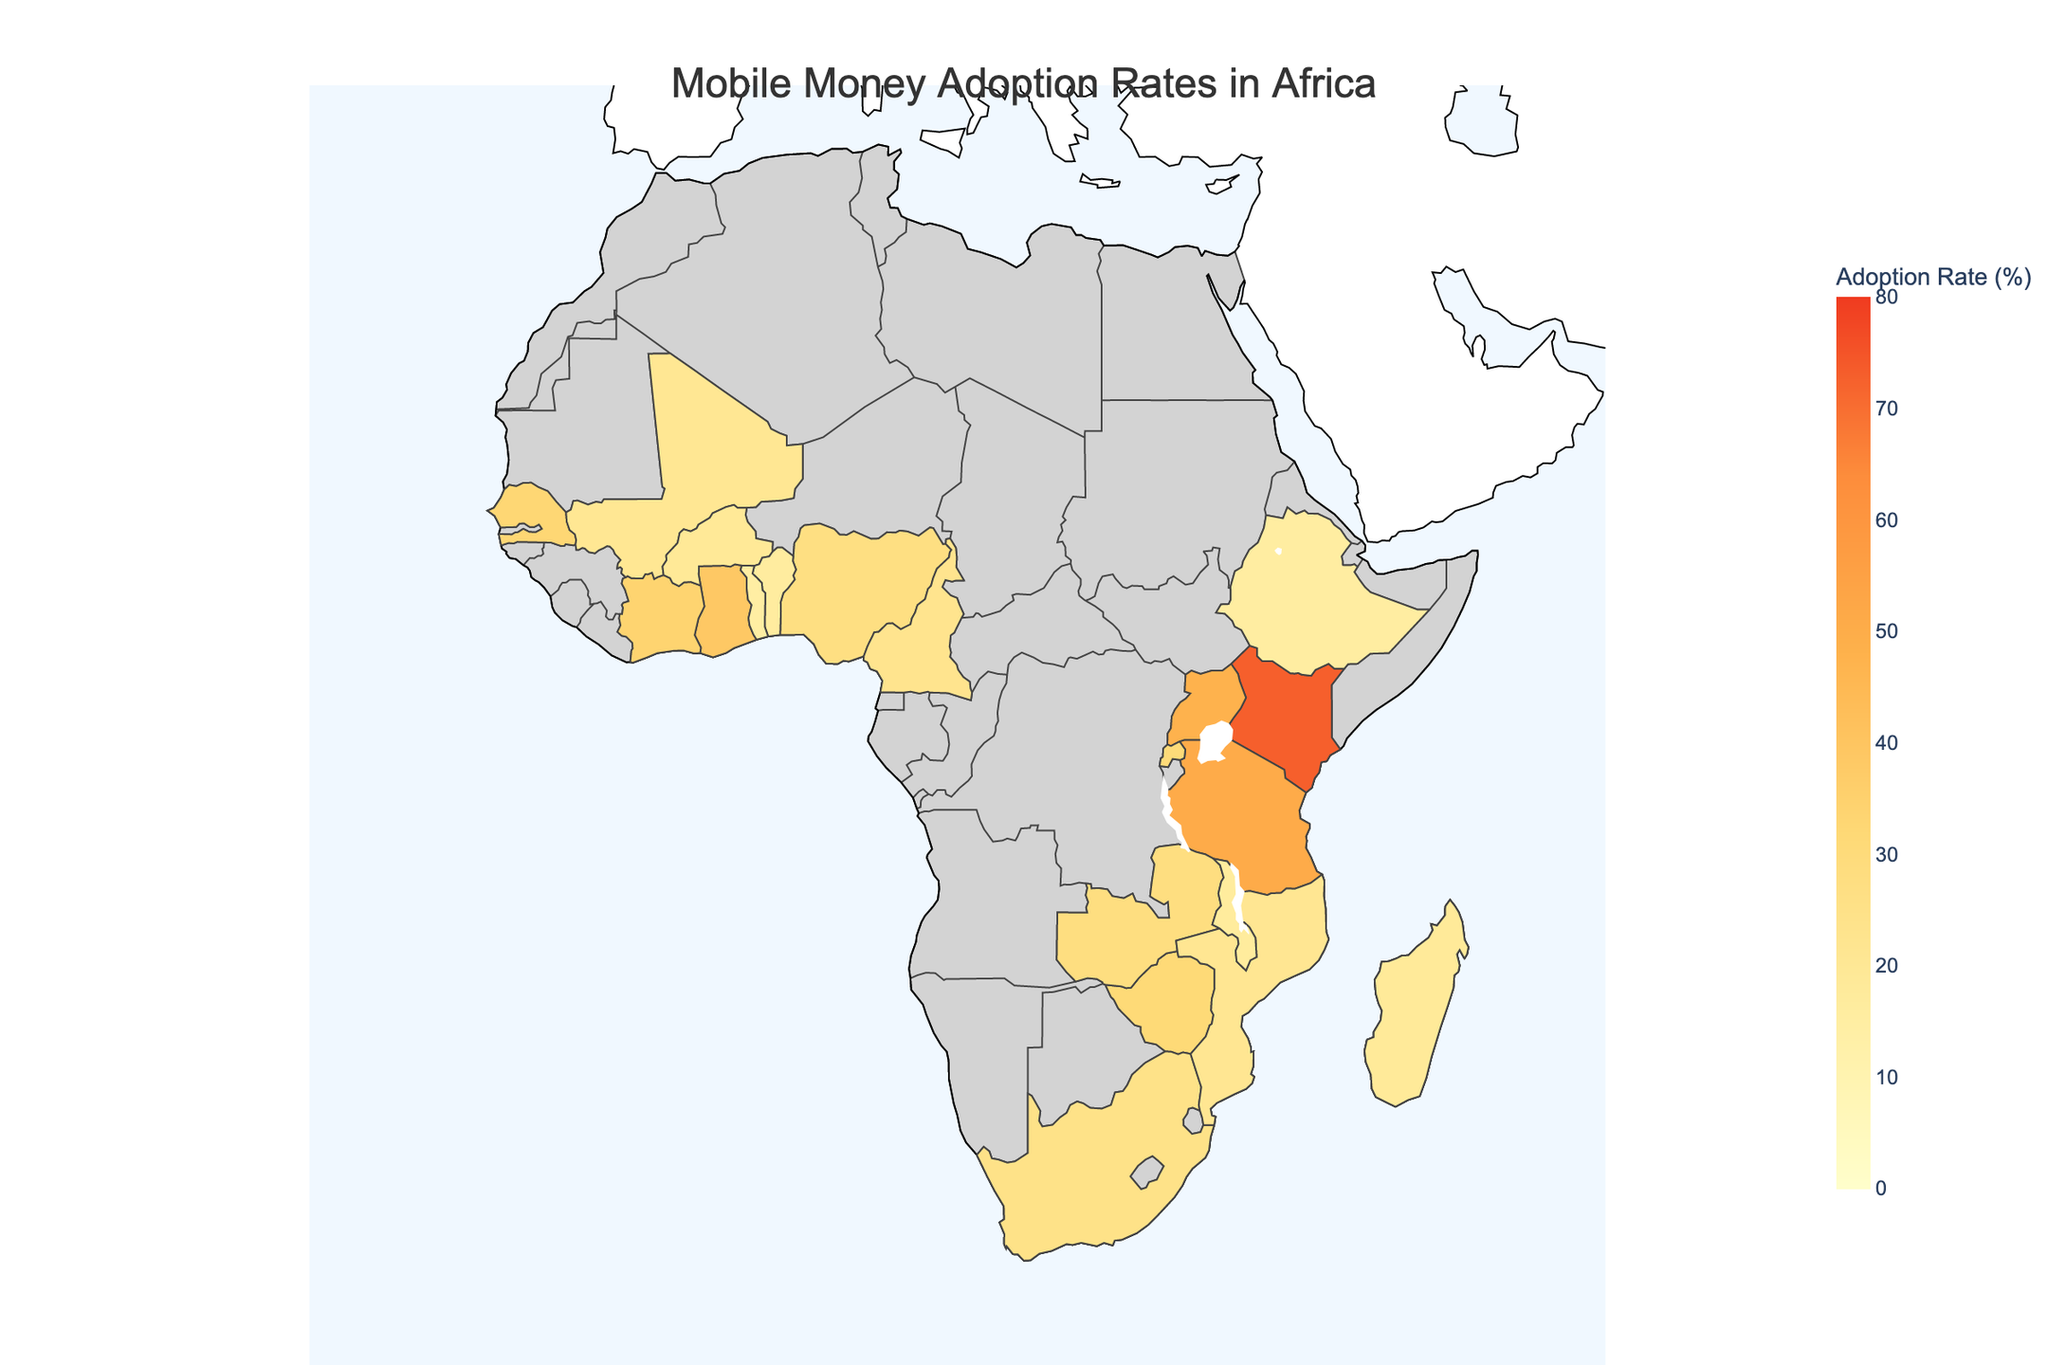What is the highest mobile money adoption rate shown in the plot? The plot shows the mobile money adoption rates for different African countries. The highest rate is represented for Kenya with a rate of 72.9%.
Answer: 72.9% Which country has the lowest mobile money adoption rate in the plot? By examining the various color intensities and corresponding adoption rates, Togo is shown to have the lowest rate at 14.9%.
Answer: Togo How many countries have an adoption rate above 30%? Identify the countries with rates above 30% in the plot. The countries are Kenya, Tanzania, Uganda, Ghana, Côte d'Ivoire, Senegal, Zimbabwe, Rwanda, and Zambia. Therefore, there are 9 countries in total.
Answer: 9 Which country has a higher mobile money adoption rate, Ghana or Nigeria? Compare the mobile money adoption rates of Ghana (38.9%) and Nigeria (27.6%) shown in the plot. Ghana has a higher rate.
Answer: Ghana What is the average mobile money adoption rate for the top 5 countries? The top 5 countries by adoption rate are Kenya (72.9%), Tanzania (51.2%), Uganda (47.8%), Ghana (38.9%), and Côte d'Ivoire (34.1%). Add these rates and divide by 5: (72.9 + 51.2 + 47.8 + 38.9 + 34.1) / 5 = 49.0%
Answer: 49.0% What is the range of the mobile money adoption rates shown in the plot? The range is calculated by subtracting the lowest adoption rate (Togo at 14.9%) from the highest (Kenya at 72.9%): 72.9% - 14.9% = 58%.
Answer: 58% Do any countries have an adoption rate between 20% and 25%? Check the plot for countries with adoption rates within this range. Cameroon (22.9%) and Mozambique (21.5%) fall within this range.
Answer: Yes, Cameroon and Mozambique Which region does the plot cover? Observe the title and layout of the plot. It mentions that the scope of the map is within "Africa."
Answer: Africa Are there more countries with adoption rates above or below 30%? Count the countries above 30% and below 30%. Above 30%: 9 countries, below 30%: 12 countries. Therefore, more countries have rates below 30%.
Answer: Below 30% What color represents the highest adoption rates in the plot? Look at the color scale on the plot. The highest adoption rates are represented by a dark red color.
Answer: Dark red 